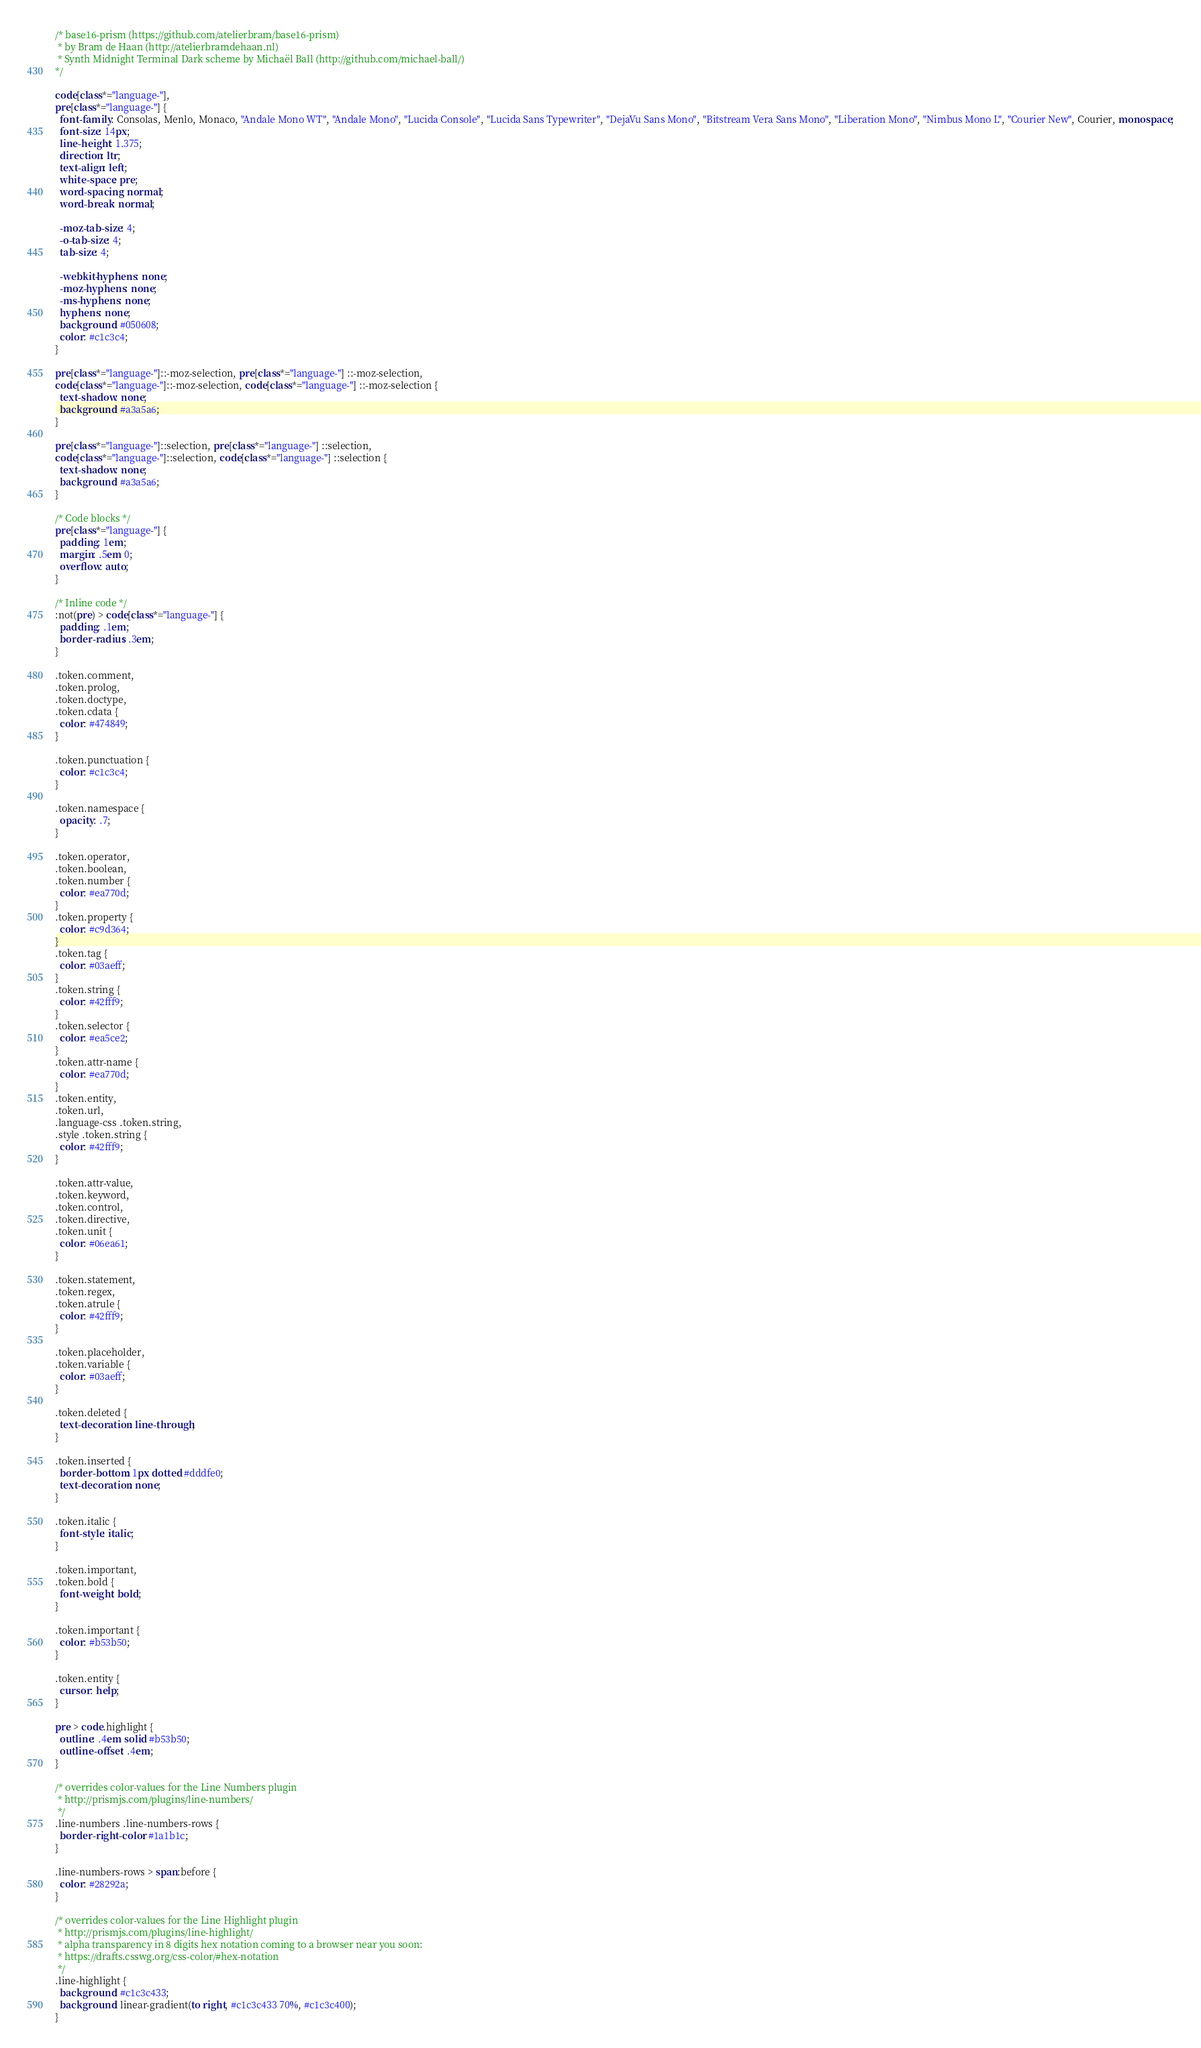Convert code to text. <code><loc_0><loc_0><loc_500><loc_500><_CSS_>/* base16-prism (https://github.com/atelierbram/base16-prism)
 * by Bram de Haan (http://atelierbramdehaan.nl)
 * Synth Midnight Terminal Dark scheme by Michaël Ball (http://github.com/michael-ball/)
*/

code[class*="language-"],
pre[class*="language-"] {
  font-family: Consolas, Menlo, Monaco, "Andale Mono WT", "Andale Mono", "Lucida Console", "Lucida Sans Typewriter", "DejaVu Sans Mono", "Bitstream Vera Sans Mono", "Liberation Mono", "Nimbus Mono L", "Courier New", Courier, monospace;
  font-size: 14px;
  line-height: 1.375;
  direction: ltr;
  text-align: left;
  white-space: pre;
  word-spacing: normal;
  word-break: normal;

  -moz-tab-size: 4;
  -o-tab-size: 4;
  tab-size: 4;

  -webkit-hyphens: none;
  -moz-hyphens: none;
  -ms-hyphens: none;
  hyphens: none;
  background: #050608;
  color: #c1c3c4;
}

pre[class*="language-"]::-moz-selection, pre[class*="language-"] ::-moz-selection,
code[class*="language-"]::-moz-selection, code[class*="language-"] ::-moz-selection {
  text-shadow: none;
  background: #a3a5a6;
}

pre[class*="language-"]::selection, pre[class*="language-"] ::selection,
code[class*="language-"]::selection, code[class*="language-"] ::selection {
  text-shadow: none;
  background: #a3a5a6;
}

/* Code blocks */
pre[class*="language-"] {
  padding: 1em;
  margin: .5em 0;
  overflow: auto;
}

/* Inline code */
:not(pre) > code[class*="language-"] {
  padding: .1em;
  border-radius: .3em;
}

.token.comment,
.token.prolog,
.token.doctype,
.token.cdata {
  color: #474849;
}

.token.punctuation {
  color: #c1c3c4;
}

.token.namespace {
  opacity: .7;
}

.token.operator,
.token.boolean,
.token.number {
  color: #ea770d;
}
.token.property {
  color: #c9d364;
}
.token.tag {
  color: #03aeff;
}
.token.string {
  color: #42fff9;
}
.token.selector {
  color: #ea5ce2;
}
.token.attr-name {
  color: #ea770d;
}
.token.entity,
.token.url,
.language-css .token.string,
.style .token.string {
  color: #42fff9;
}

.token.attr-value,
.token.keyword,
.token.control,
.token.directive,
.token.unit {
  color: #06ea61;
}

.token.statement,
.token.regex,
.token.atrule {
  color: #42fff9;
}

.token.placeholder,
.token.variable {
  color: #03aeff;
}

.token.deleted {
  text-decoration: line-through;
}

.token.inserted {
  border-bottom: 1px dotted #dddfe0;
  text-decoration: none;
}

.token.italic {
  font-style: italic;
}

.token.important,
.token.bold {
  font-weight: bold;
}

.token.important {
  color: #b53b50;
}

.token.entity {
  cursor: help;
}

pre > code.highlight {
  outline: .4em solid #b53b50;
  outline-offset: .4em;
}

/* overrides color-values for the Line Numbers plugin
 * http://prismjs.com/plugins/line-numbers/
 */
.line-numbers .line-numbers-rows {
  border-right-color: #1a1b1c;
}

.line-numbers-rows > span:before {
  color: #28292a;
}

/* overrides color-values for the Line Highlight plugin
 * http://prismjs.com/plugins/line-highlight/
 * alpha transparency in 8 digits hex notation coming to a browser near you soon:
 * https://drafts.csswg.org/css-color/#hex-notation
 */
.line-highlight {
  background: #c1c3c433;
  background: linear-gradient(to right, #c1c3c433 70%, #c1c3c400);
}
</code> 